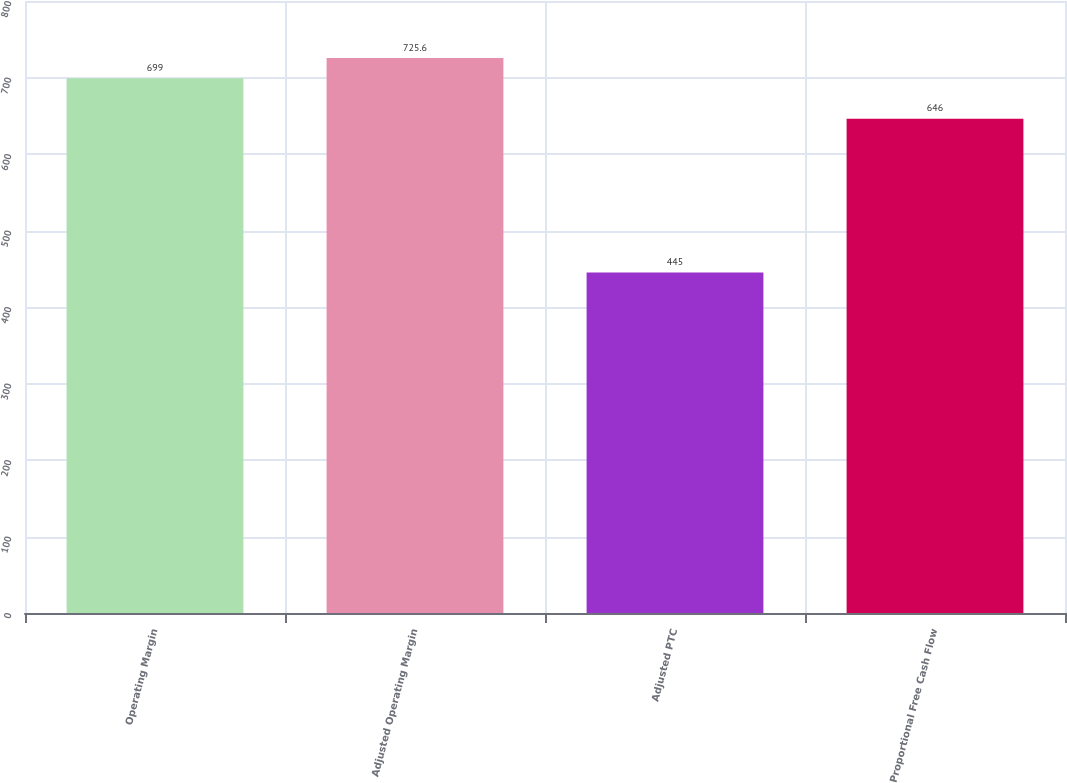Convert chart to OTSL. <chart><loc_0><loc_0><loc_500><loc_500><bar_chart><fcel>Operating Margin<fcel>Adjusted Operating Margin<fcel>Adjusted PTC<fcel>Proportional Free Cash Flow<nl><fcel>699<fcel>725.6<fcel>445<fcel>646<nl></chart> 